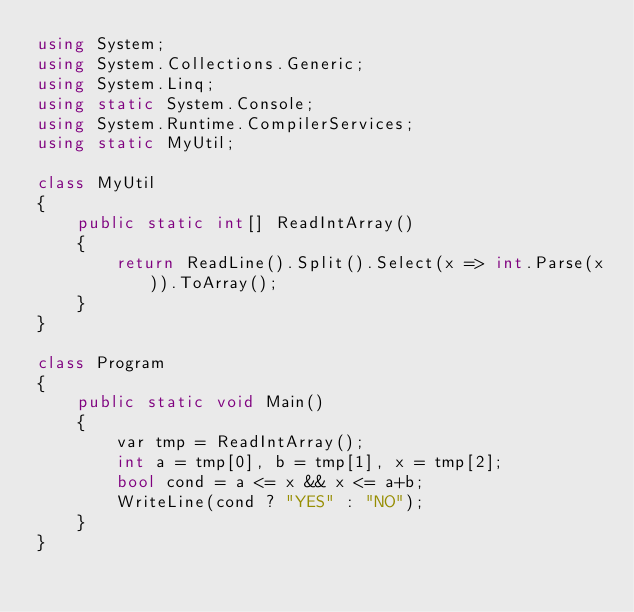Convert code to text. <code><loc_0><loc_0><loc_500><loc_500><_C#_>using System;
using System.Collections.Generic;
using System.Linq;
using static System.Console;
using System.Runtime.CompilerServices;
using static MyUtil;

class MyUtil
{
    public static int[] ReadIntArray()
    {
        return ReadLine().Split().Select(x => int.Parse(x)).ToArray();
    }
}

class Program
{
    public static void Main()
    {
        var tmp = ReadIntArray();
        int a = tmp[0], b = tmp[1], x = tmp[2];
        bool cond = a <= x && x <= a+b;
        WriteLine(cond ? "YES" : "NO");
    }
}
</code> 